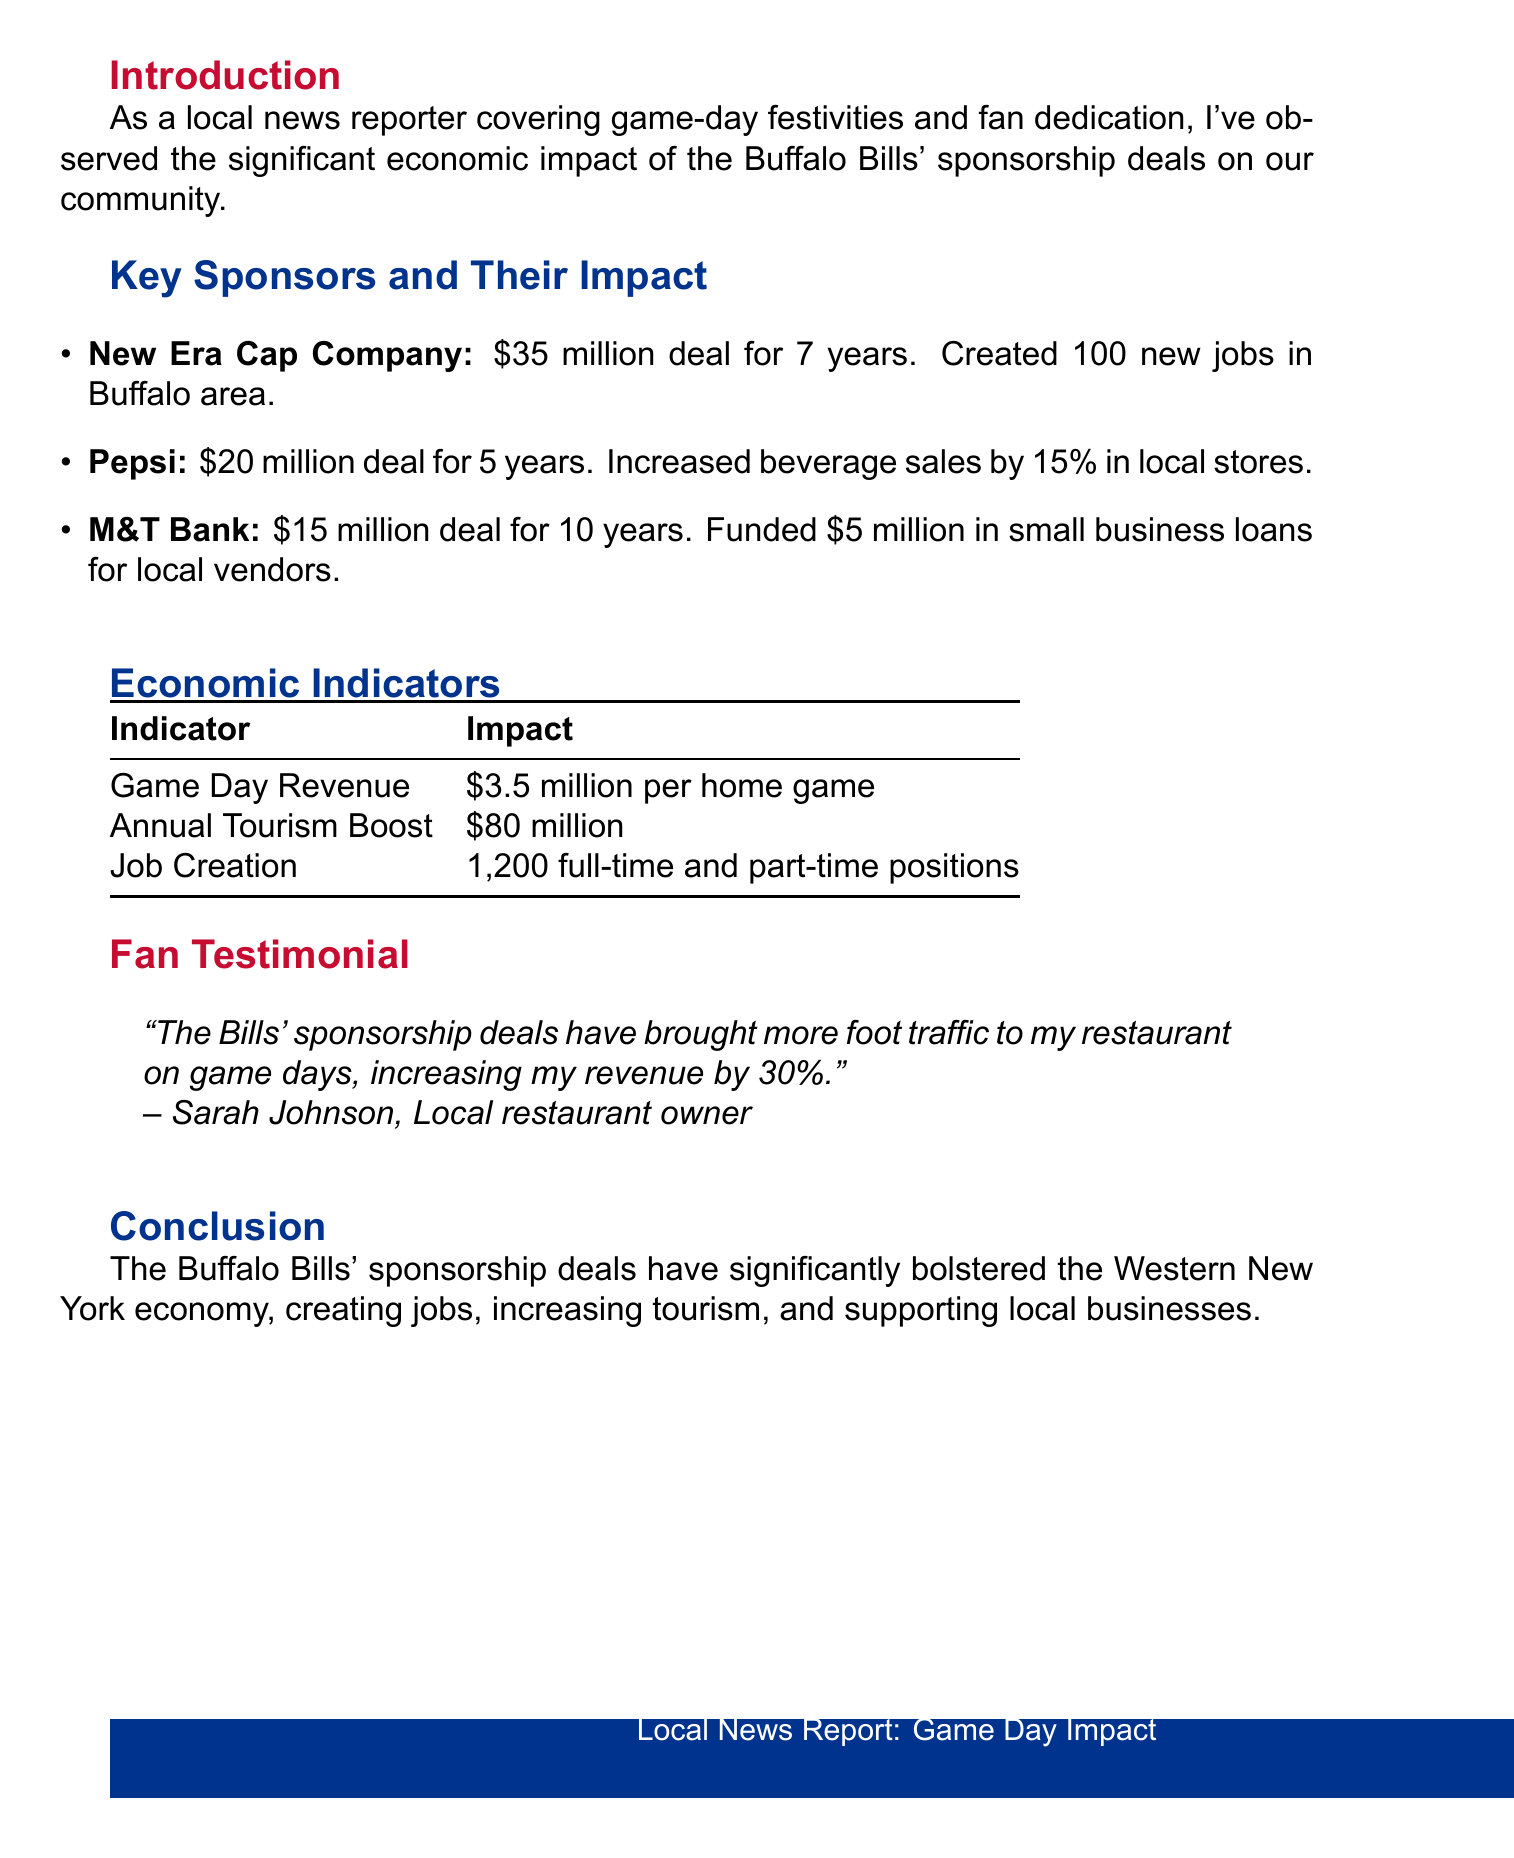What is the report title? The title of the report is stated at the beginning of the document and refers to the economic impact of sponsorship deals.
Answer: Impact of Buffalo Bills' Sponsorship Deals on Western New York Economy How much is the sponsorship deal with New Era Cap Company worth? The deal value with New Era Cap Company is specified in the key sponsors section of the document.
Answer: $35 million What percentage increase in beverage sales did Pepsi achieve? The percentage increase is mentioned in the local impact for Pepsi within the key sponsors section.
Answer: 15% How many jobs were created due to the sponsorship deals? The total number of jobs created is provided under economic indicators in the document.
Answer: 1,200 full-time and part-time positions What was the annual tourism boost attributed to the Buffalo Bills? The annual tourism boost is listed in the economic indicators section of the report.
Answer: $80 million What did local restaurant owner Sarah Johnson say about the economic impact? Sarah Johnson's quote provides insight into how the sponsorship deals affected her business, as included in the fan testimonial section.
Answer: "increasing my revenue by 30%." What is the duration of the deal with M&T Bank? The duration of M&T Bank's deal is specified alongside its value in the key sponsors section of the document.
Answer: 10 years How much revenue is generated per home game? This revenue figure is provided as part of the economic indicators in the report.
Answer: $3.5 million per home game 